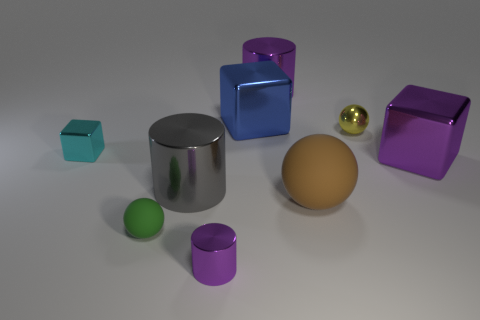There is a brown object that is made of the same material as the green object; what is its shape? sphere 